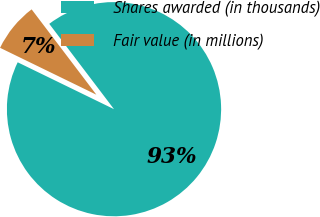<chart> <loc_0><loc_0><loc_500><loc_500><pie_chart><fcel>Shares awarded (in thousands)<fcel>Fair value (in millions)<nl><fcel>92.54%<fcel>7.46%<nl></chart> 